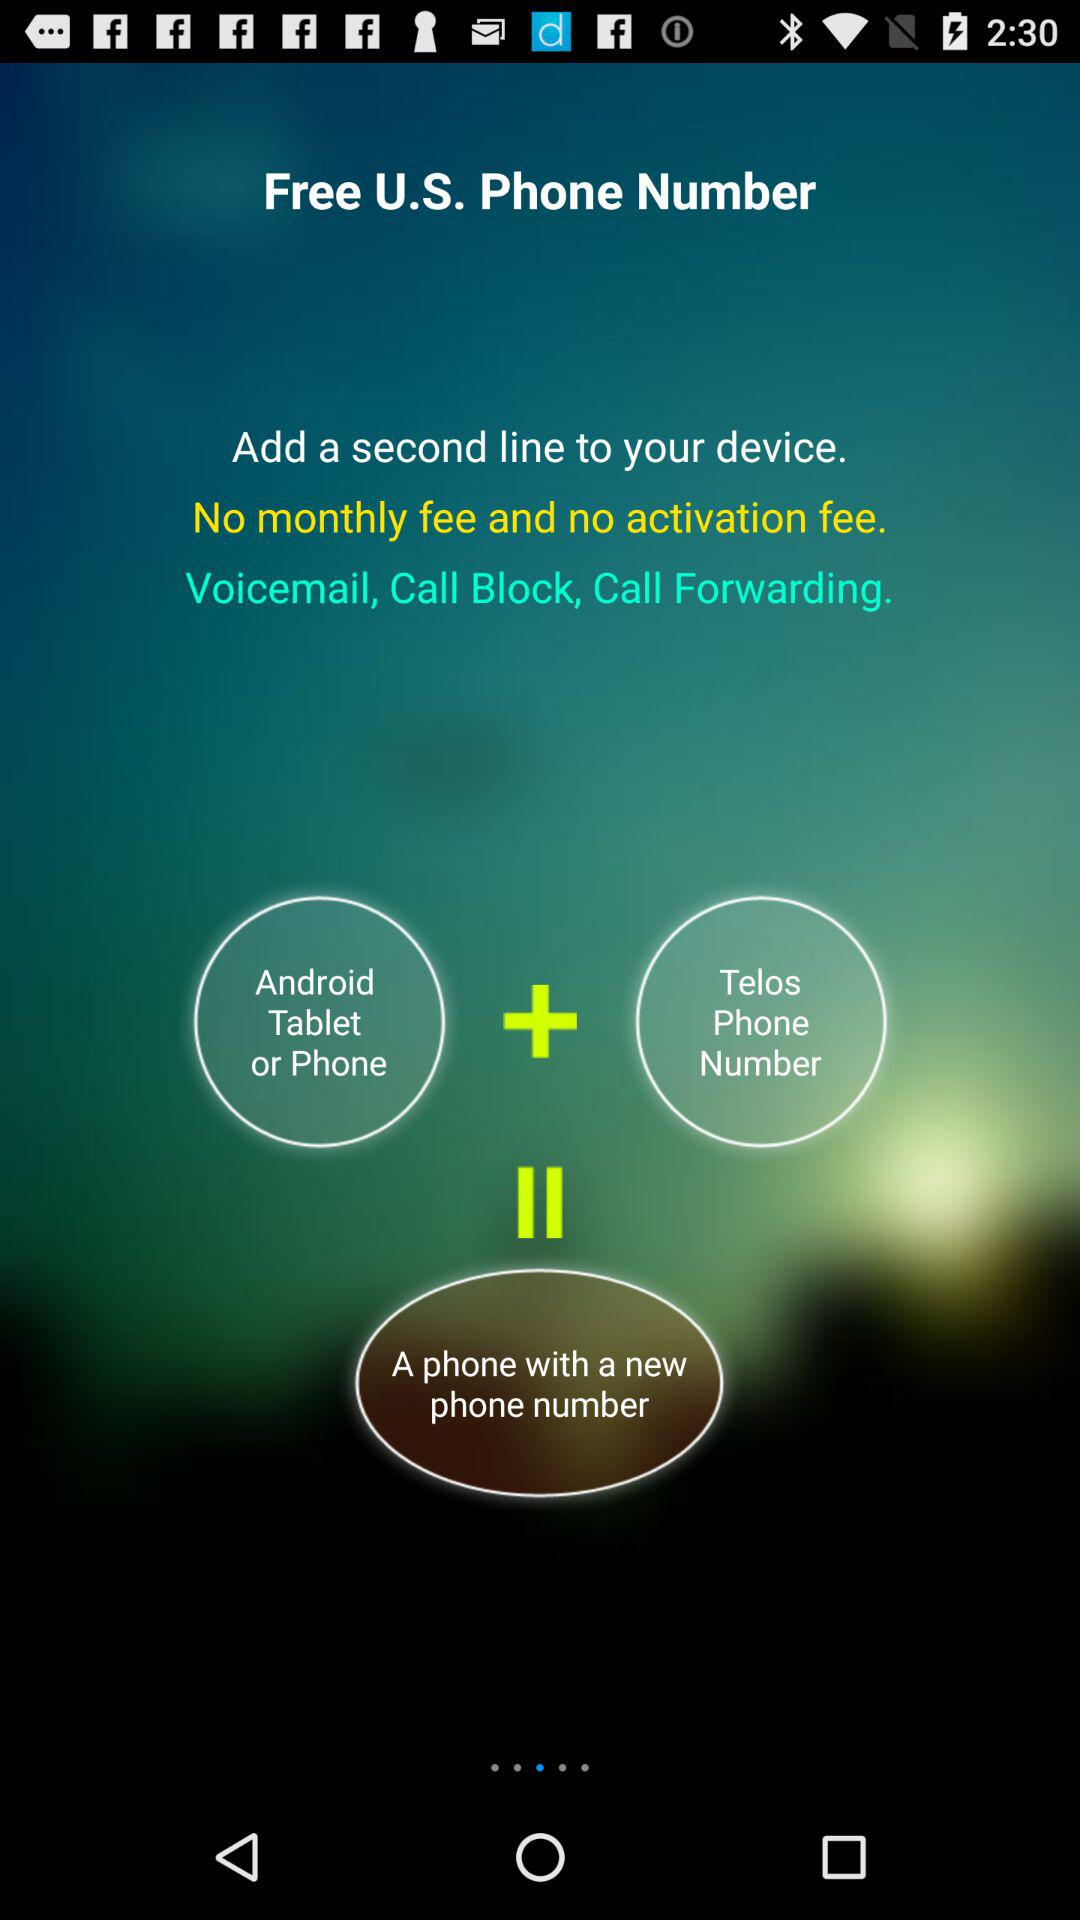How many steps are there in the process of adding a second line?
Answer the question using a single word or phrase. 3 